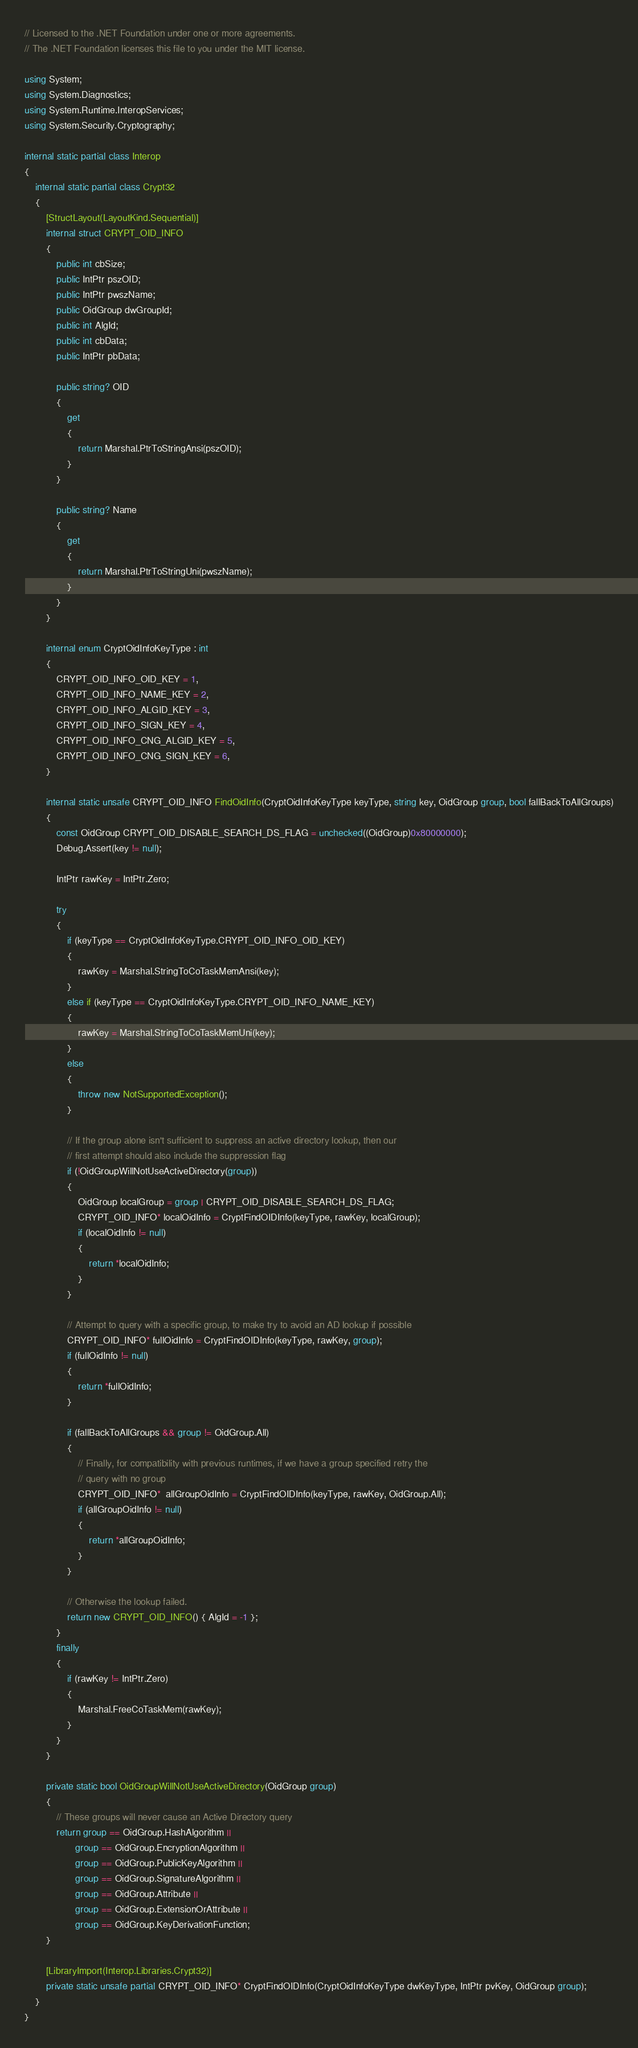<code> <loc_0><loc_0><loc_500><loc_500><_C#_>// Licensed to the .NET Foundation under one or more agreements.
// The .NET Foundation licenses this file to you under the MIT license.

using System;
using System.Diagnostics;
using System.Runtime.InteropServices;
using System.Security.Cryptography;

internal static partial class Interop
{
    internal static partial class Crypt32
    {
        [StructLayout(LayoutKind.Sequential)]
        internal struct CRYPT_OID_INFO
        {
            public int cbSize;
            public IntPtr pszOID;
            public IntPtr pwszName;
            public OidGroup dwGroupId;
            public int AlgId;
            public int cbData;
            public IntPtr pbData;

            public string? OID
            {
                get
                {
                    return Marshal.PtrToStringAnsi(pszOID);
                }
            }

            public string? Name
            {
                get
                {
                    return Marshal.PtrToStringUni(pwszName);
                }
            }
        }

        internal enum CryptOidInfoKeyType : int
        {
            CRYPT_OID_INFO_OID_KEY = 1,
            CRYPT_OID_INFO_NAME_KEY = 2,
            CRYPT_OID_INFO_ALGID_KEY = 3,
            CRYPT_OID_INFO_SIGN_KEY = 4,
            CRYPT_OID_INFO_CNG_ALGID_KEY = 5,
            CRYPT_OID_INFO_CNG_SIGN_KEY = 6,
        }

        internal static unsafe CRYPT_OID_INFO FindOidInfo(CryptOidInfoKeyType keyType, string key, OidGroup group, bool fallBackToAllGroups)
        {
            const OidGroup CRYPT_OID_DISABLE_SEARCH_DS_FLAG = unchecked((OidGroup)0x80000000);
            Debug.Assert(key != null);

            IntPtr rawKey = IntPtr.Zero;

            try
            {
                if (keyType == CryptOidInfoKeyType.CRYPT_OID_INFO_OID_KEY)
                {
                    rawKey = Marshal.StringToCoTaskMemAnsi(key);
                }
                else if (keyType == CryptOidInfoKeyType.CRYPT_OID_INFO_NAME_KEY)
                {
                    rawKey = Marshal.StringToCoTaskMemUni(key);
                }
                else
                {
                    throw new NotSupportedException();
                }

                // If the group alone isn't sufficient to suppress an active directory lookup, then our
                // first attempt should also include the suppression flag
                if (!OidGroupWillNotUseActiveDirectory(group))
                {
                    OidGroup localGroup = group | CRYPT_OID_DISABLE_SEARCH_DS_FLAG;
                    CRYPT_OID_INFO* localOidInfo = CryptFindOIDInfo(keyType, rawKey, localGroup);
                    if (localOidInfo != null)
                    {
                        return *localOidInfo;
                    }
                }

                // Attempt to query with a specific group, to make try to avoid an AD lookup if possible
                CRYPT_OID_INFO* fullOidInfo = CryptFindOIDInfo(keyType, rawKey, group);
                if (fullOidInfo != null)
                {
                    return *fullOidInfo;
                }

                if (fallBackToAllGroups && group != OidGroup.All)
                {
                    // Finally, for compatibility with previous runtimes, if we have a group specified retry the
                    // query with no group
                    CRYPT_OID_INFO*  allGroupOidInfo = CryptFindOIDInfo(keyType, rawKey, OidGroup.All);
                    if (allGroupOidInfo != null)
                    {
                        return *allGroupOidInfo;
                    }
                }

                // Otherwise the lookup failed.
                return new CRYPT_OID_INFO() { AlgId = -1 };
            }
            finally
            {
                if (rawKey != IntPtr.Zero)
                {
                    Marshal.FreeCoTaskMem(rawKey);
                }
            }
        }

        private static bool OidGroupWillNotUseActiveDirectory(OidGroup group)
        {
            // These groups will never cause an Active Directory query
            return group == OidGroup.HashAlgorithm ||
                   group == OidGroup.EncryptionAlgorithm ||
                   group == OidGroup.PublicKeyAlgorithm ||
                   group == OidGroup.SignatureAlgorithm ||
                   group == OidGroup.Attribute ||
                   group == OidGroup.ExtensionOrAttribute ||
                   group == OidGroup.KeyDerivationFunction;
        }

        [LibraryImport(Interop.Libraries.Crypt32)]
        private static unsafe partial CRYPT_OID_INFO* CryptFindOIDInfo(CryptOidInfoKeyType dwKeyType, IntPtr pvKey, OidGroup group);
    }
}
</code> 